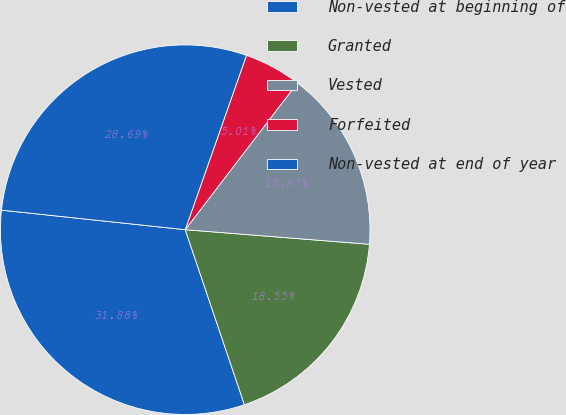Convert chart to OTSL. <chart><loc_0><loc_0><loc_500><loc_500><pie_chart><fcel>Non-vested at beginning of<fcel>Granted<fcel>Vested<fcel>Forfeited<fcel>Non-vested at end of year<nl><fcel>31.88%<fcel>18.55%<fcel>15.87%<fcel>5.01%<fcel>28.69%<nl></chart> 